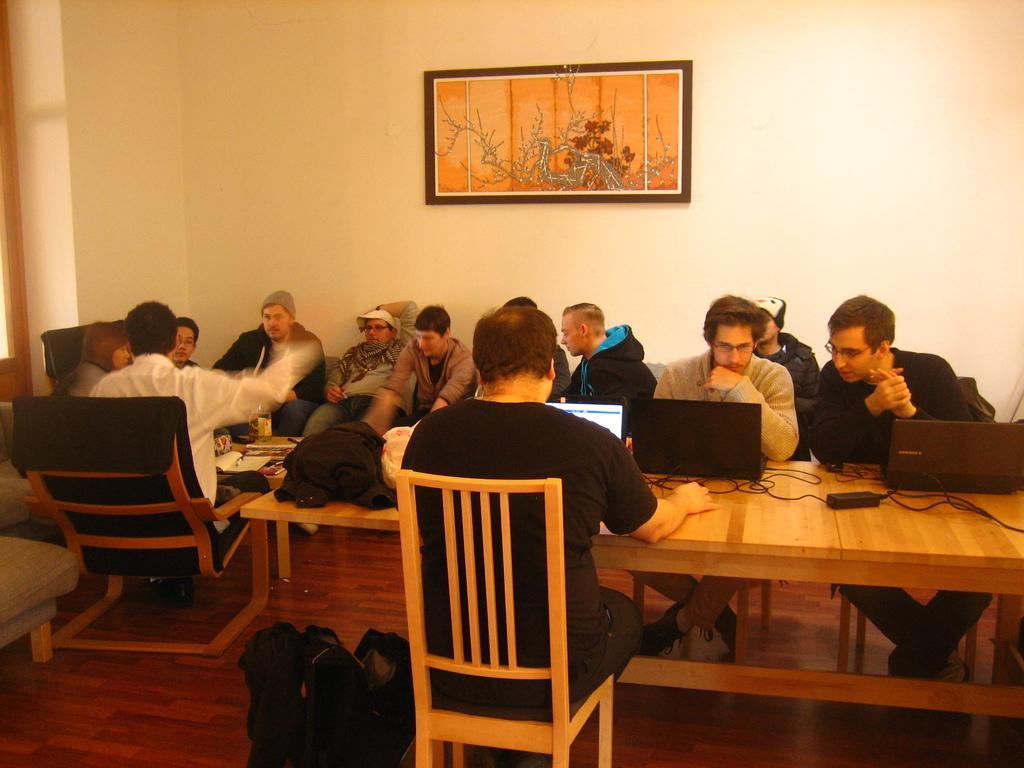In one or two sentences, can you explain what this image depicts? In the middle of the image a man is siting on a chair. Bottom right side of the image there is a table, On the table there is a laptop. At the top of the image there is a wall, On the wall there is a frame. In the middle of the image a few people are sitting. Bottom of the image there is a bag. 